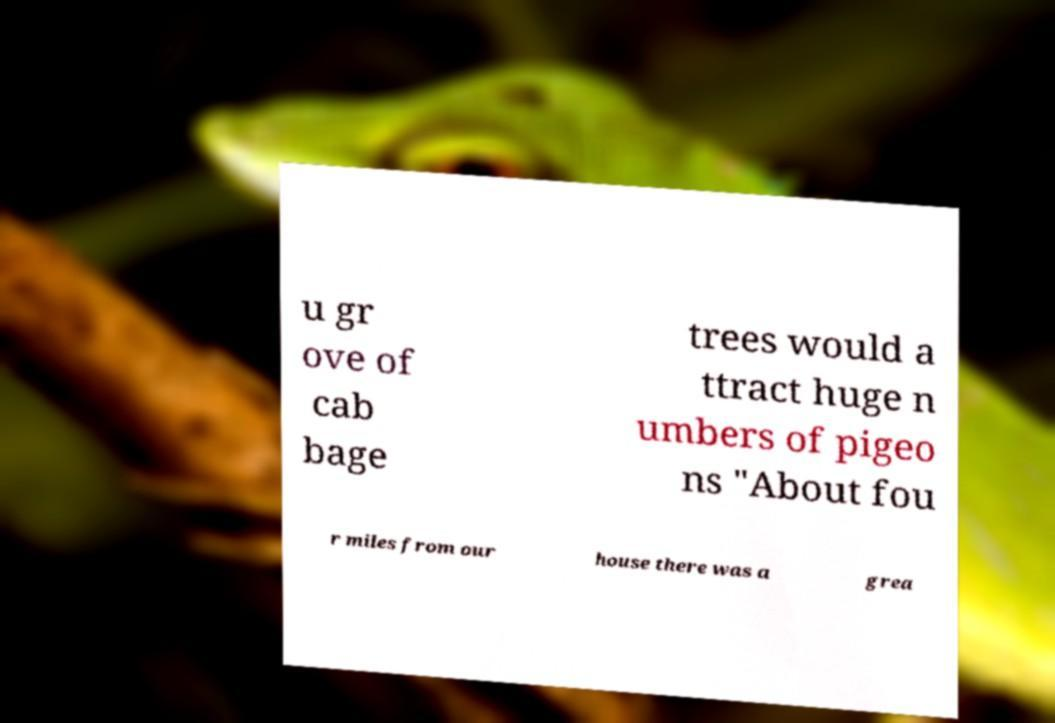Could you extract and type out the text from this image? u gr ove of cab bage trees would a ttract huge n umbers of pigeo ns "About fou r miles from our house there was a grea 